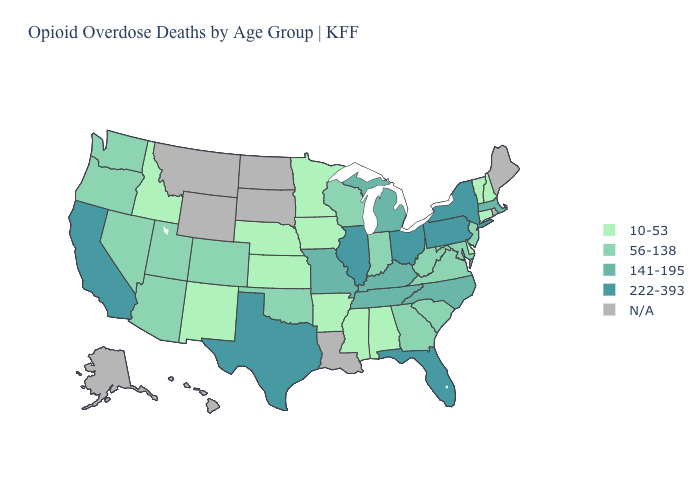How many symbols are there in the legend?
Short answer required. 5. Among the states that border Nebraska , which have the lowest value?
Short answer required. Iowa, Kansas. Which states hav the highest value in the West?
Be succinct. California. Does North Carolina have the highest value in the USA?
Give a very brief answer. No. Does the map have missing data?
Quick response, please. Yes. What is the value of Texas?
Be succinct. 222-393. What is the value of Washington?
Give a very brief answer. 56-138. What is the lowest value in the MidWest?
Keep it brief. 10-53. Name the states that have a value in the range 56-138?
Concise answer only. Arizona, Colorado, Georgia, Indiana, Maryland, Nevada, New Jersey, Oklahoma, Oregon, South Carolina, Utah, Virginia, Washington, West Virginia, Wisconsin. Among the states that border Kentucky , which have the highest value?
Answer briefly. Illinois, Ohio. Does Ohio have the highest value in the USA?
Keep it brief. Yes. What is the value of New Jersey?
Short answer required. 56-138. Name the states that have a value in the range 56-138?
Concise answer only. Arizona, Colorado, Georgia, Indiana, Maryland, Nevada, New Jersey, Oklahoma, Oregon, South Carolina, Utah, Virginia, Washington, West Virginia, Wisconsin. Name the states that have a value in the range N/A?
Answer briefly. Alaska, Hawaii, Louisiana, Maine, Montana, North Dakota, Rhode Island, South Dakota, Wyoming. 